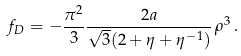Convert formula to latex. <formula><loc_0><loc_0><loc_500><loc_500>f _ { D } = - \frac { \pi ^ { 2 } } { 3 } \frac { 2 a } { \sqrt { 3 } ( 2 + \eta + \eta ^ { - 1 } ) } \, \rho ^ { 3 } \, .</formula> 